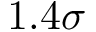<formula> <loc_0><loc_0><loc_500><loc_500>1 . 4 \sigma</formula> 